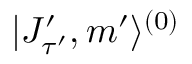Convert formula to latex. <formula><loc_0><loc_0><loc_500><loc_500>| J _ { \tau ^ { \prime } } ^ { \prime } , m ^ { \prime } \rangle ^ { ( 0 ) }</formula> 